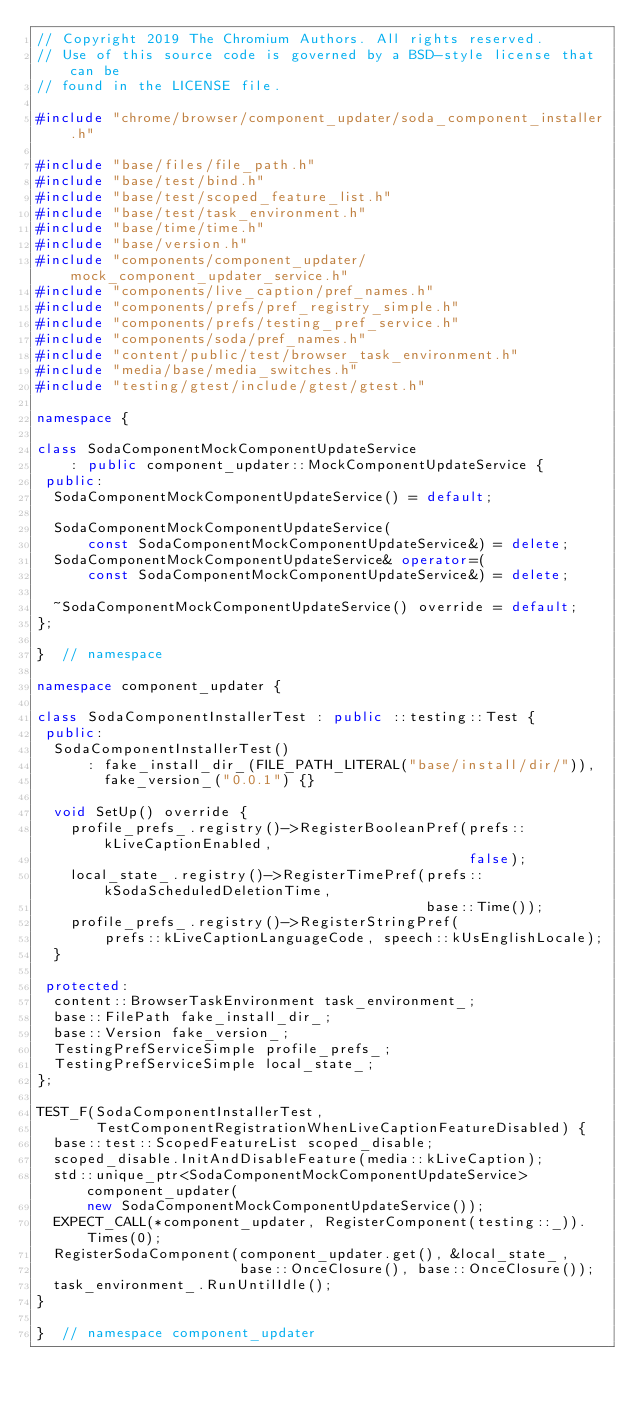Convert code to text. <code><loc_0><loc_0><loc_500><loc_500><_C++_>// Copyright 2019 The Chromium Authors. All rights reserved.
// Use of this source code is governed by a BSD-style license that can be
// found in the LICENSE file.

#include "chrome/browser/component_updater/soda_component_installer.h"

#include "base/files/file_path.h"
#include "base/test/bind.h"
#include "base/test/scoped_feature_list.h"
#include "base/test/task_environment.h"
#include "base/time/time.h"
#include "base/version.h"
#include "components/component_updater/mock_component_updater_service.h"
#include "components/live_caption/pref_names.h"
#include "components/prefs/pref_registry_simple.h"
#include "components/prefs/testing_pref_service.h"
#include "components/soda/pref_names.h"
#include "content/public/test/browser_task_environment.h"
#include "media/base/media_switches.h"
#include "testing/gtest/include/gtest/gtest.h"

namespace {

class SodaComponentMockComponentUpdateService
    : public component_updater::MockComponentUpdateService {
 public:
  SodaComponentMockComponentUpdateService() = default;

  SodaComponentMockComponentUpdateService(
      const SodaComponentMockComponentUpdateService&) = delete;
  SodaComponentMockComponentUpdateService& operator=(
      const SodaComponentMockComponentUpdateService&) = delete;

  ~SodaComponentMockComponentUpdateService() override = default;
};

}  // namespace

namespace component_updater {

class SodaComponentInstallerTest : public ::testing::Test {
 public:
  SodaComponentInstallerTest()
      : fake_install_dir_(FILE_PATH_LITERAL("base/install/dir/")),
        fake_version_("0.0.1") {}

  void SetUp() override {
    profile_prefs_.registry()->RegisterBooleanPref(prefs::kLiveCaptionEnabled,
                                                   false);
    local_state_.registry()->RegisterTimePref(prefs::kSodaScheduledDeletionTime,
                                              base::Time());
    profile_prefs_.registry()->RegisterStringPref(
        prefs::kLiveCaptionLanguageCode, speech::kUsEnglishLocale);
  }

 protected:
  content::BrowserTaskEnvironment task_environment_;
  base::FilePath fake_install_dir_;
  base::Version fake_version_;
  TestingPrefServiceSimple profile_prefs_;
  TestingPrefServiceSimple local_state_;
};

TEST_F(SodaComponentInstallerTest,
       TestComponentRegistrationWhenLiveCaptionFeatureDisabled) {
  base::test::ScopedFeatureList scoped_disable;
  scoped_disable.InitAndDisableFeature(media::kLiveCaption);
  std::unique_ptr<SodaComponentMockComponentUpdateService> component_updater(
      new SodaComponentMockComponentUpdateService());
  EXPECT_CALL(*component_updater, RegisterComponent(testing::_)).Times(0);
  RegisterSodaComponent(component_updater.get(), &local_state_,
                        base::OnceClosure(), base::OnceClosure());
  task_environment_.RunUntilIdle();
}

}  // namespace component_updater
</code> 